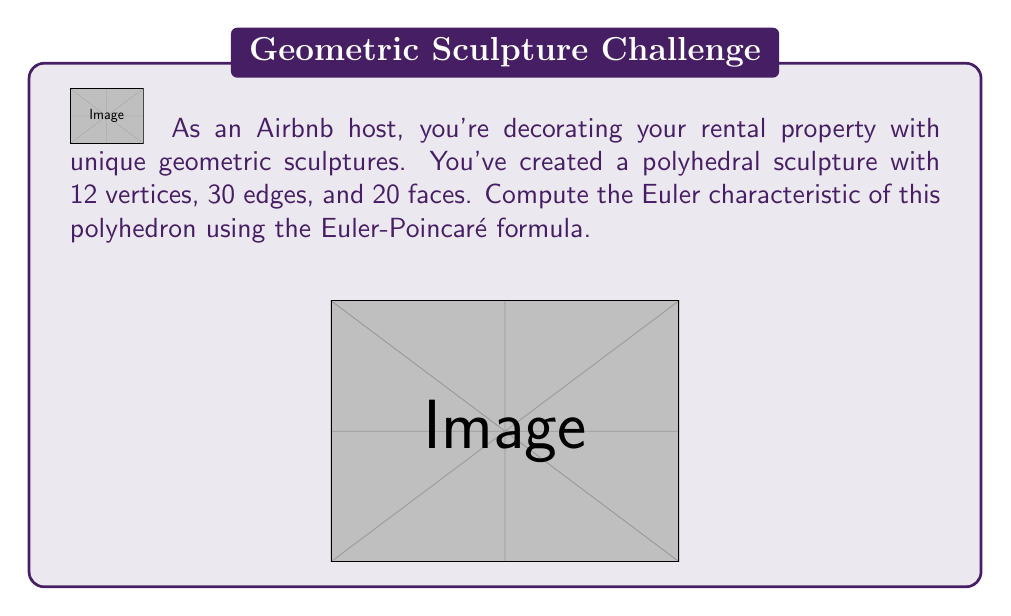Give your solution to this math problem. To compute the Euler characteristic of the polyhedron, we'll use the Euler-Poincaré formula:

$$\chi = V - E + F$$

Where:
$\chi$ is the Euler characteristic
$V$ is the number of vertices
$E$ is the number of edges
$F$ is the number of faces

Given:
- Vertices (V) = 12
- Edges (E) = 30
- Faces (F) = 20

Let's substitute these values into the formula:

$$\begin{align}
\chi &= V - E + F \\
&= 12 - 30 + 20 \\
&= -18 + 20 \\
&= 2
\end{align}$$

The Euler characteristic of this polyhedron is 2, which is consistent with the fact that it's a convex polyhedron homeomorphic to a sphere. This result is expected for all convex polyhedra and many other closed surfaces without holes.

It's worth noting that the Euler characteristic is a topological invariant, meaning it doesn't change under continuous deformations of the shape. This property makes it useful for classifying different types of surfaces and understanding their fundamental structure.
Answer: $\chi = 2$ 